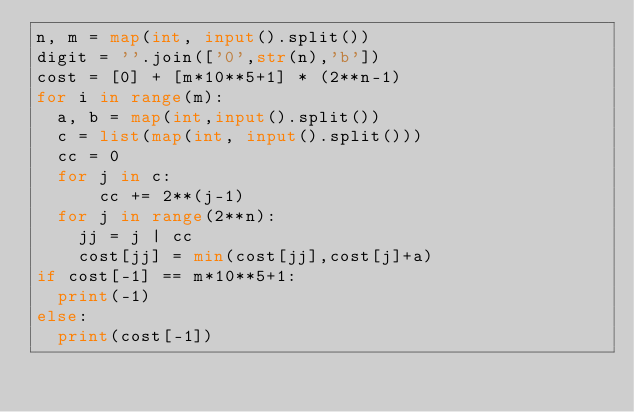<code> <loc_0><loc_0><loc_500><loc_500><_Python_>n, m = map(int, input().split())
digit = ''.join(['0',str(n),'b'])
cost = [0] + [m*10**5+1] * (2**n-1)
for i in range(m):
  a, b = map(int,input().split())
  c = list(map(int, input().split()))
  cc = 0
  for j in c:
      cc += 2**(j-1)
  for j in range(2**n):
    jj = j | cc
    cost[jj] = min(cost[jj],cost[j]+a)
if cost[-1] == m*10**5+1:
  print(-1)
else:
  print(cost[-1])</code> 